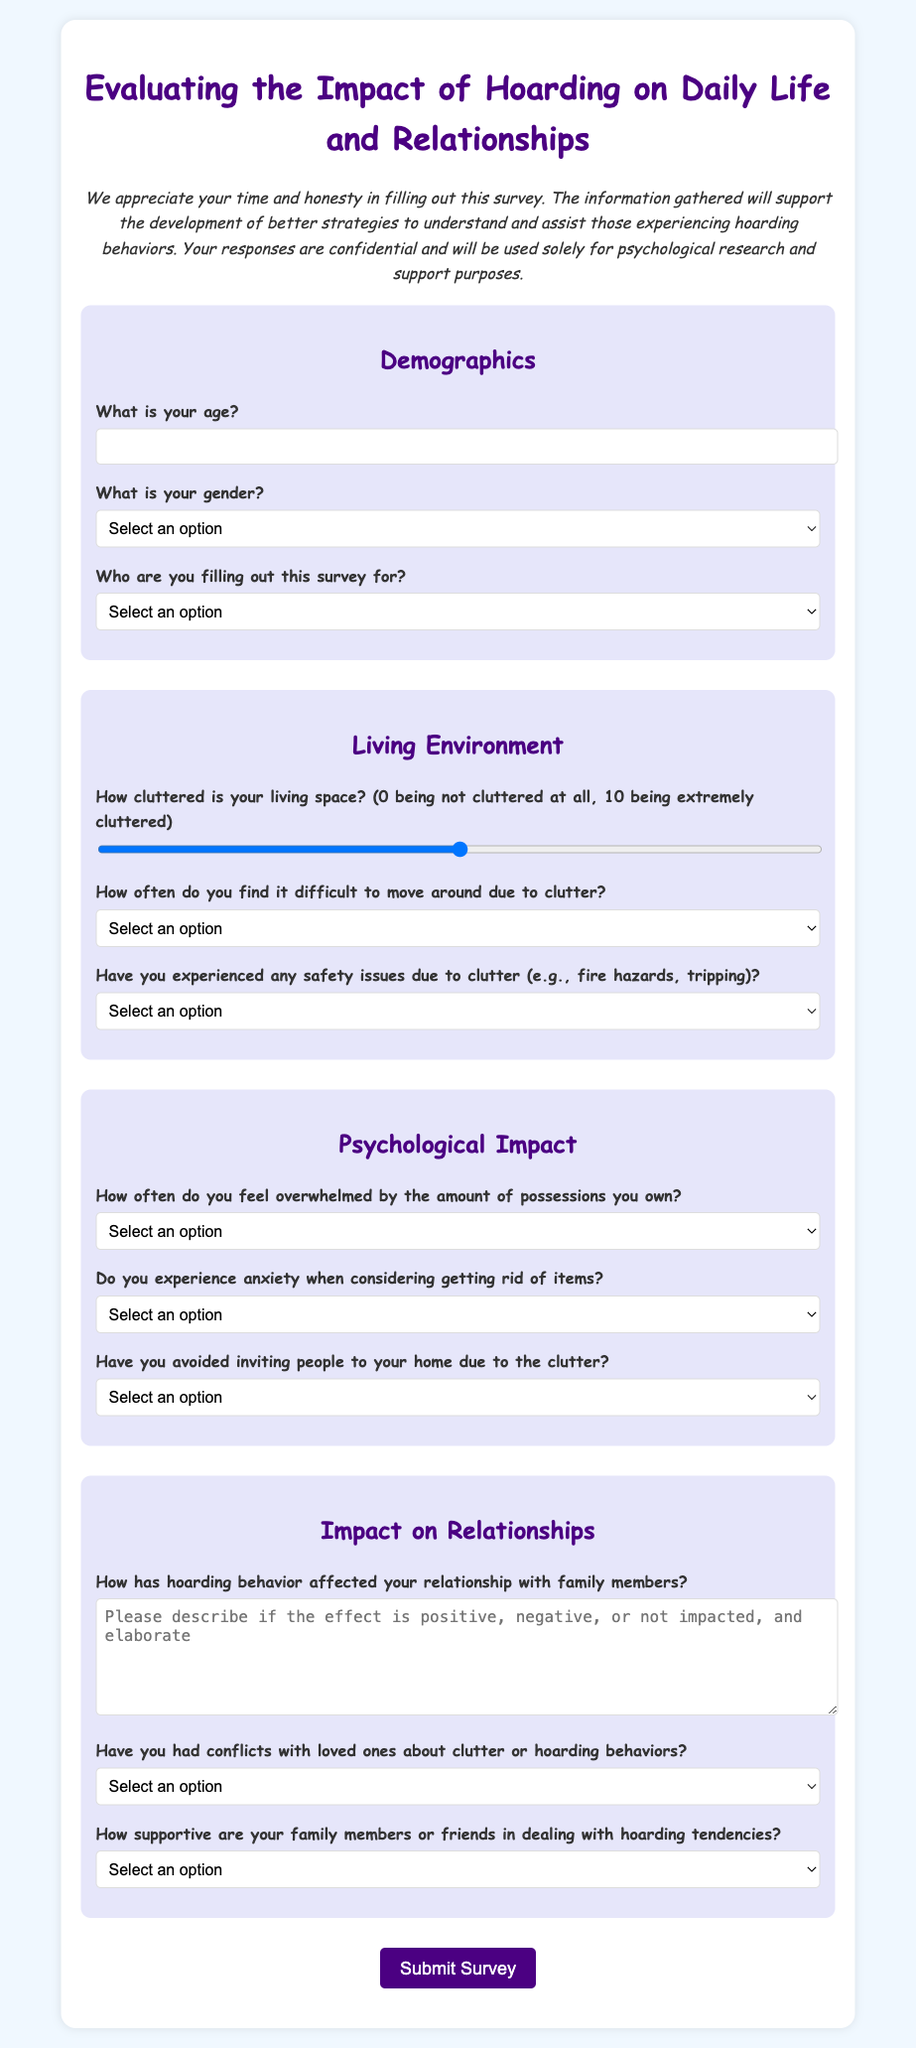What is the title of the survey? The title of the survey is presented at the top of the document.
Answer: Evaluating the Impact of Hoarding on Daily Life and Relationships What is the required age input type? The age input field clearly specifies that it requires a number as a response.
Answer: number What is the maximum level of clutter on the scale provided? The range input for clutter level shows the maximum value as indicated in the document.
Answer: 10 What label corresponds to the frequency of feeling overwhelmed by possessions? The question about feeling overwhelmed is clearly labeled in the psychological impact section.
Answer: How often do you feel overwhelmed by the amount of possessions you own? How supportive are family members or friends described in the document? The document includes a question about the level of support from family or friends in relation to hoarding tendencies.
Answer: How supportive are your family members or friends in dealing with hoarding tendencies? 